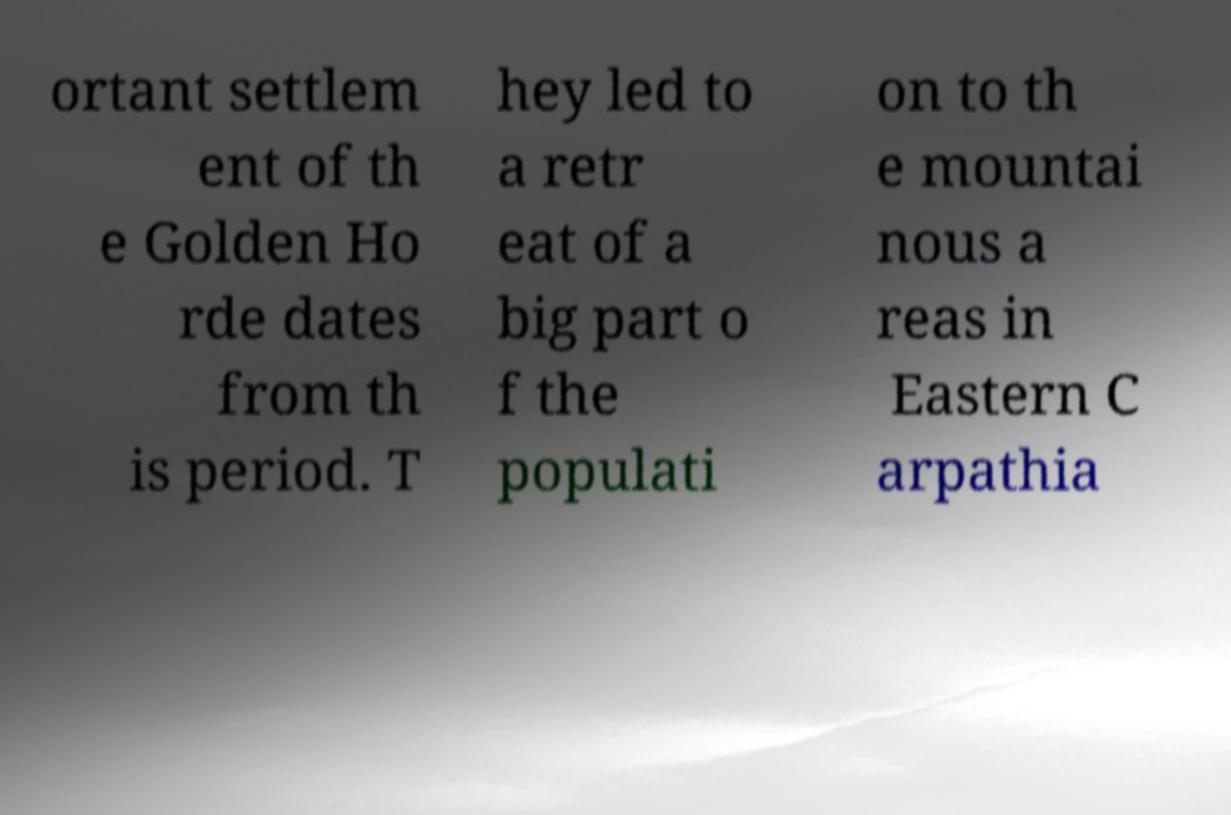Please read and relay the text visible in this image. What does it say? ortant settlem ent of th e Golden Ho rde dates from th is period. T hey led to a retr eat of a big part o f the populati on to th e mountai nous a reas in Eastern C arpathia 